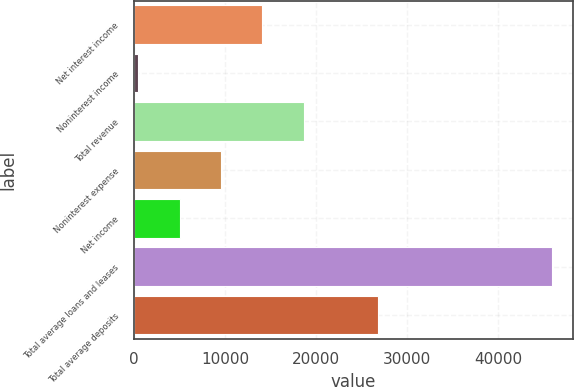Convert chart. <chart><loc_0><loc_0><loc_500><loc_500><bar_chart><fcel>Net interest income<fcel>Noninterest income<fcel>Total revenue<fcel>Noninterest expense<fcel>Net income<fcel>Total average loans and leases<fcel>Total average deposits<nl><fcel>14097.1<fcel>466<fcel>18640.8<fcel>9553.4<fcel>5009.7<fcel>45903<fcel>26811<nl></chart> 